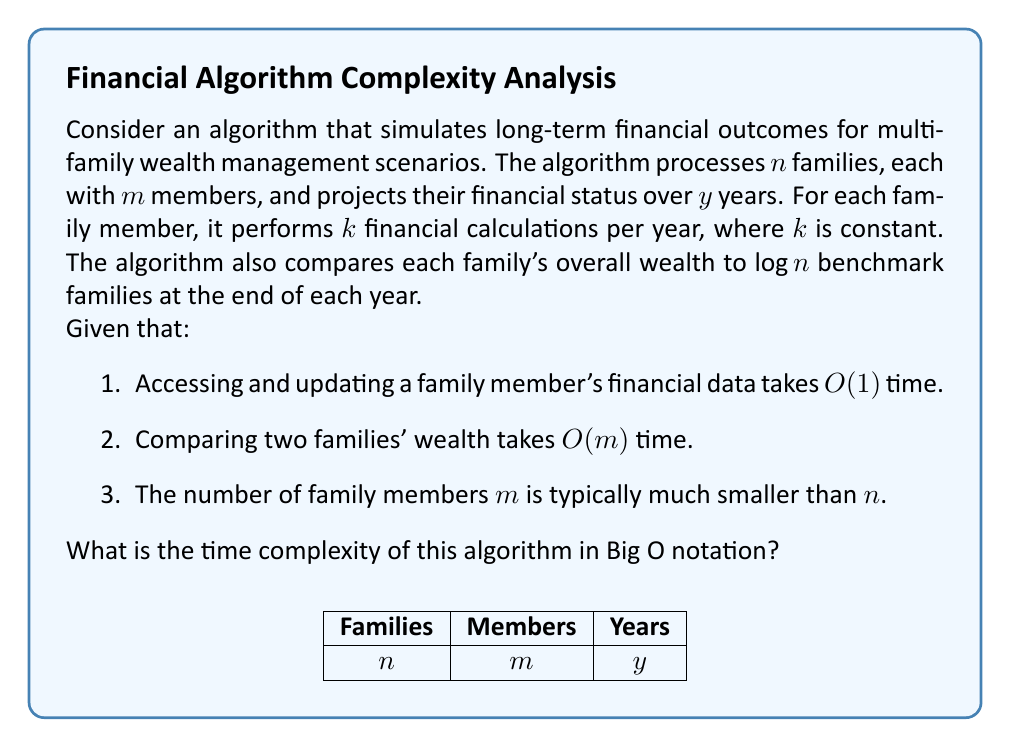Teach me how to tackle this problem. Let's break down the algorithm's operations and analyze their time complexity:

1. Processing families and their members:
   - We have $n$ families, each with $m$ members.
   - For each member, we perform $k$ calculations per year.
   - This is done for $y$ years.
   - Time complexity for this part: $O(n \cdot m \cdot k \cdot y)$

2. Comparing families to benchmarks:
   - We compare each family to $\log n$ benchmark families.
   - Comparison is done at the end of each year.
   - Each comparison takes $O(m)$ time.
   - This is done for $n$ families and $y$ years.
   - Time complexity for this part: $O(n \cdot \log n \cdot m \cdot y)$

3. Combining the two parts:
   Total time complexity = $O(n \cdot m \cdot k \cdot y + n \cdot \log n \cdot m \cdot y)$
                         = $O(n \cdot m \cdot y \cdot (k + \log n))$

4. Simplifying:
   - Since $k$ is constant, we can remove it from the Big O notation.
   - The dominant term inside the parentheses will be $\log n$ for large values of $n$.

Therefore, the simplified time complexity is $O(n \cdot m \cdot y \cdot \log n)$.

Note: Although $m$ is typically much smaller than $n$, we keep it in the notation as it's not specified to be a constant.
Answer: $O(n \cdot m \cdot y \cdot \log n)$ 